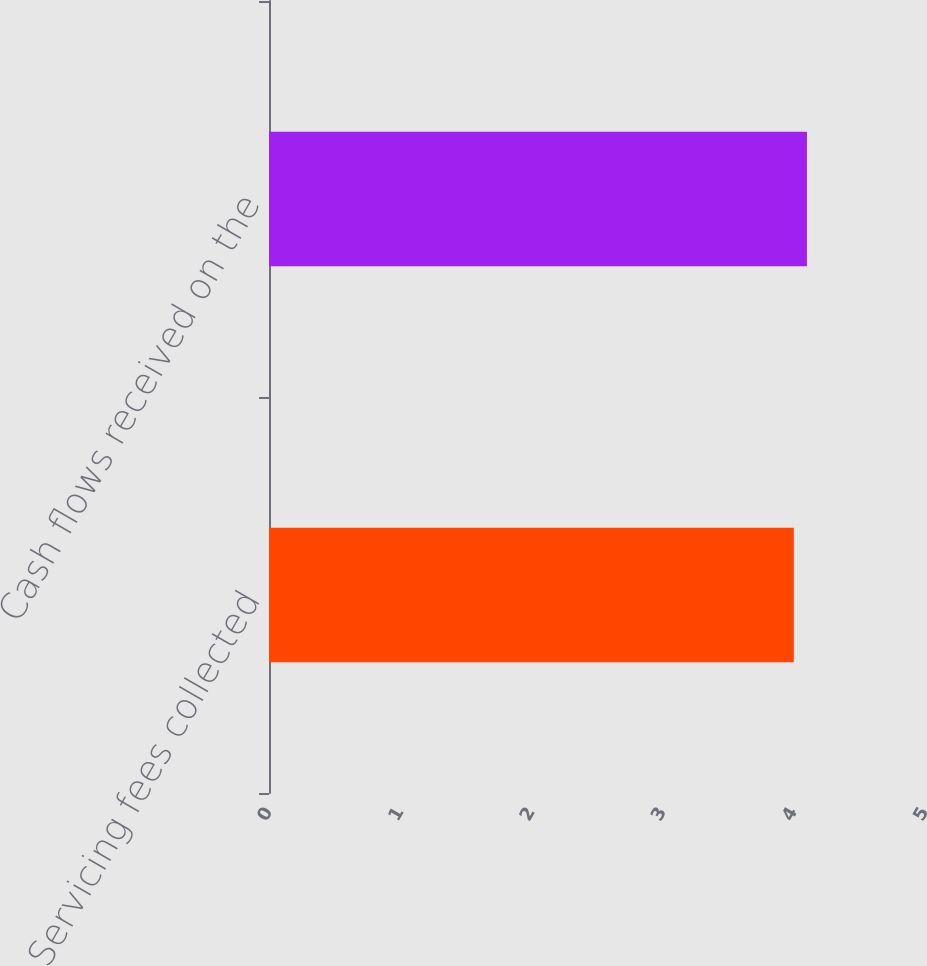Convert chart. <chart><loc_0><loc_0><loc_500><loc_500><bar_chart><fcel>Servicing fees collected<fcel>Cash flows received on the<nl><fcel>4<fcel>4.1<nl></chart> 